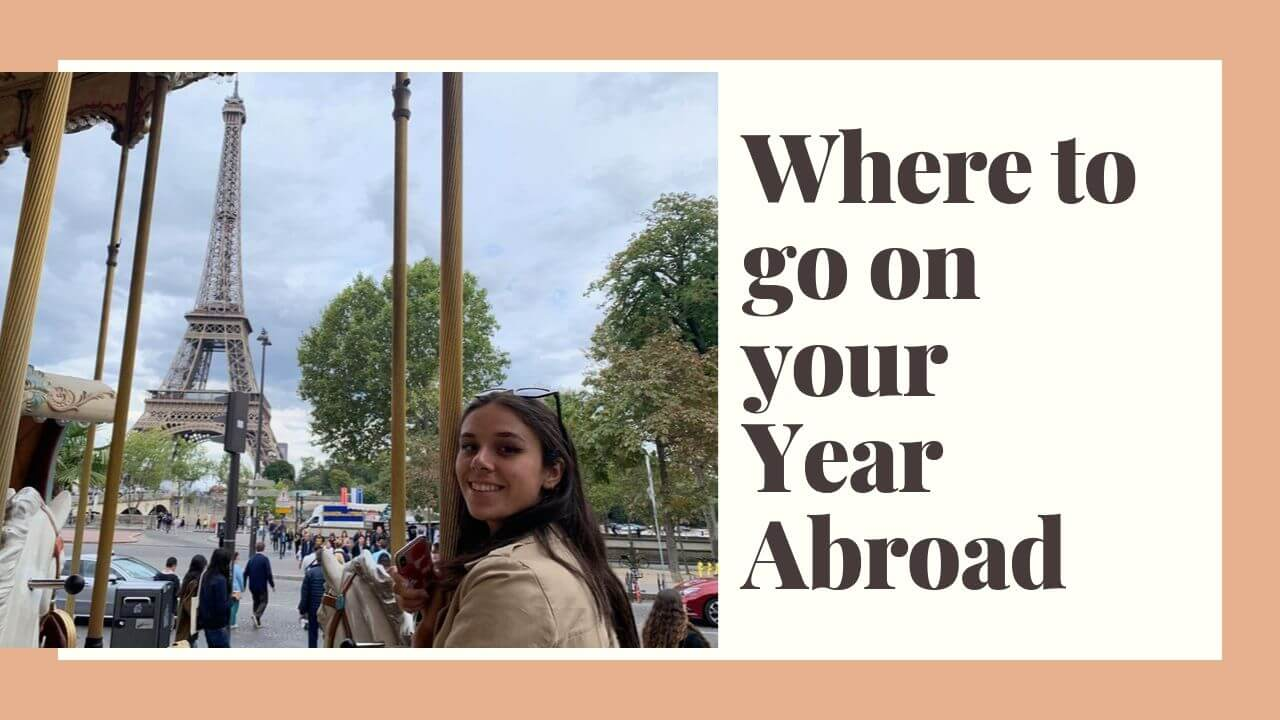If the carousel in the image were magical and could transport riders to any place in the world, where might the woman choose to go next? If the carousel were magical and could transport the woman to any place in the world, she might choose to visit Kyoto in Japan. With cherry blossoms in full bloom, ancient temples to explore, and serene tea houses, Kyoto offers a completely different yet equally enriching cultural experience. The idea of wandering through bamboo forests, participating in traditional tea ceremonies, and immersing herself in Japan’s unique blend of tradition and modernity would be too enticing to resist. 